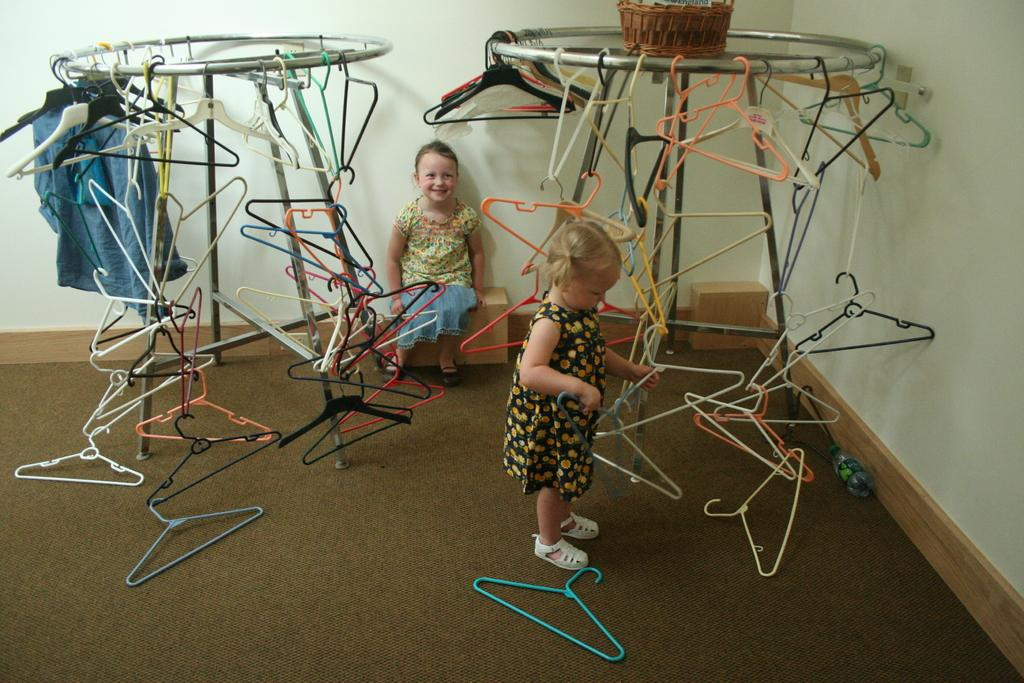How many girls are present in the image? There are two girls in the image. What are the positions of the girls in the image? One girl is sitting, and the other is standing. What objects can be seen in the image related to hanging clothes? There are cloth hangers in the image. What type of container is visible in the image? There is a basket in the image. What type of liquid-holding object is present in the image? There is a bottle in the image. How many stands can be seen in the image? There are two stands in the image. What type of veil can be seen on the cook in the image? There is no cook or veil present in the image. 